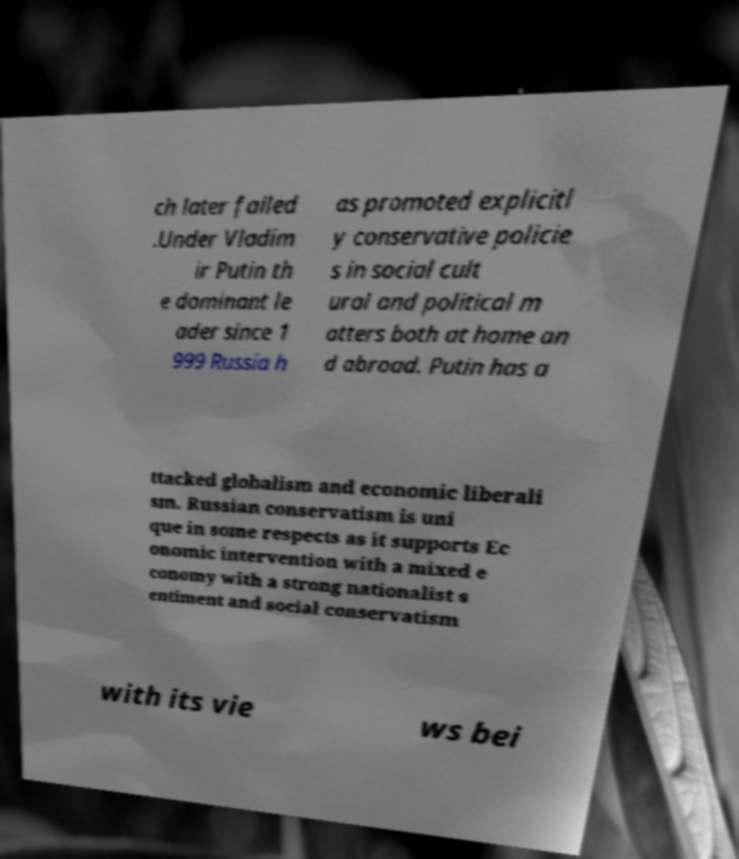Please read and relay the text visible in this image. What does it say? ch later failed .Under Vladim ir Putin th e dominant le ader since 1 999 Russia h as promoted explicitl y conservative policie s in social cult ural and political m atters both at home an d abroad. Putin has a ttacked globalism and economic liberali sm. Russian conservatism is uni que in some respects as it supports Ec onomic intervention with a mixed e conomy with a strong nationalist s entiment and social conservatism with its vie ws bei 